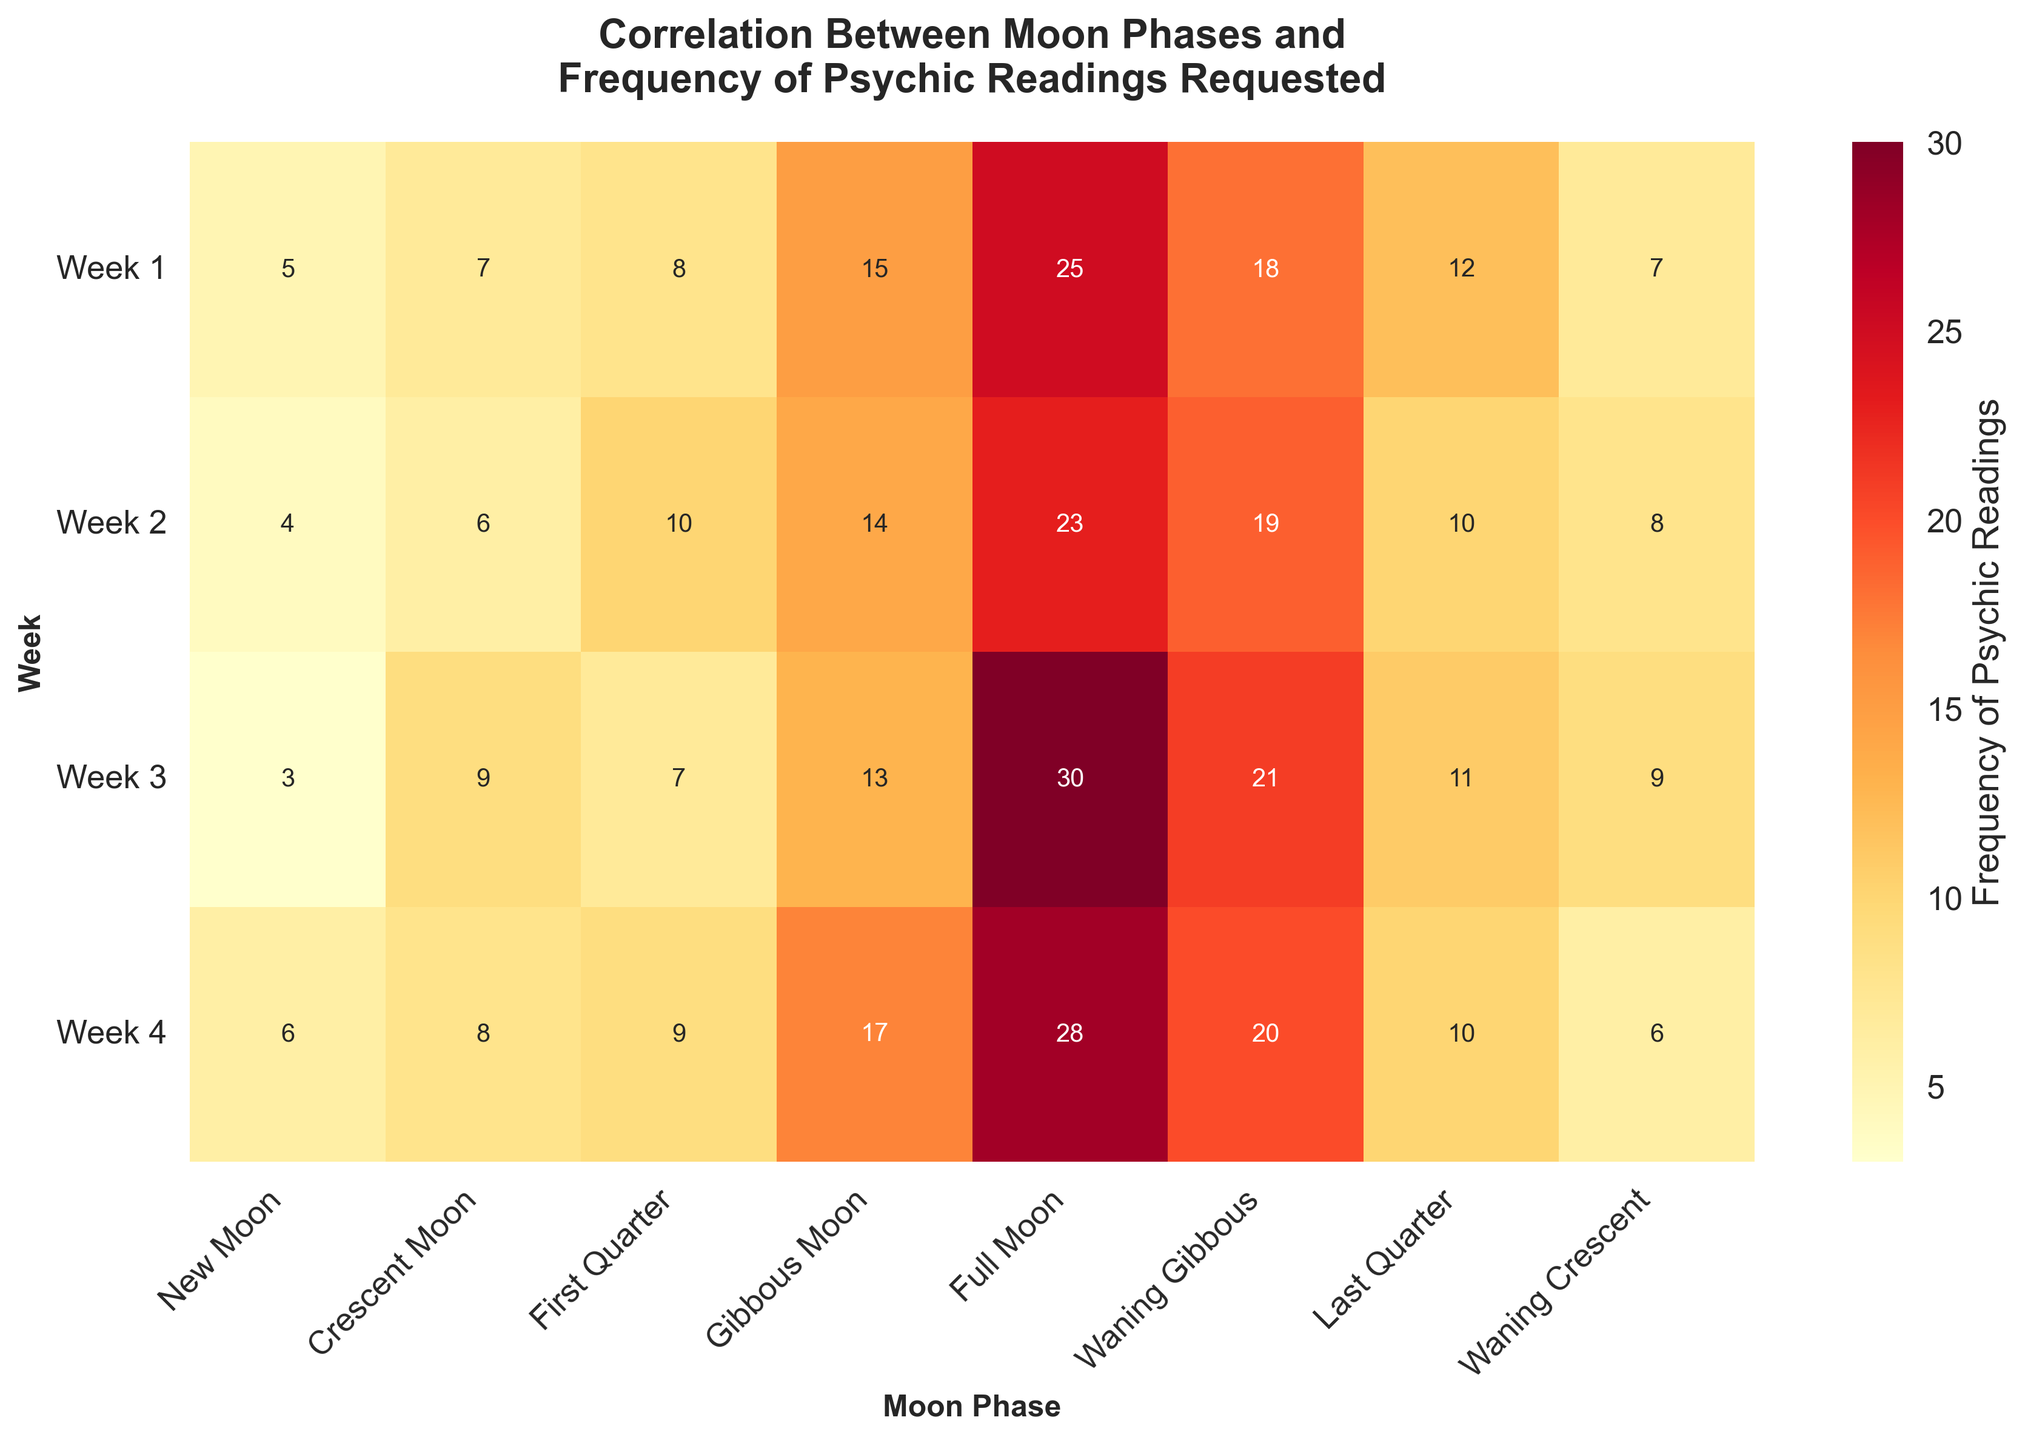What is the title of the figure? The title of the figure is generally displayed at the top. Here it says 'Correlation Between Moon Phases and Frequency of Psychic Readings Requested'.
Answer: Correlation Between Moon Phases and Frequency of Psychic Readings Requested Which Moon Phase has the highest frequency of psychic readings requested in Week 3? To determine this, look at the row labeled 'Week 3' and find the highest value. The highest value in this row is 30, which corresponds to the 'Full Moon'.
Answer: Full Moon What is the sum of psychic readings requested for the 'Waning Gibbous' phase across all weeks? Look at the 'Waning Gibbous' column and add the values: 18 + 19 + 21 + 20. The total is 78.
Answer: 78 Which Moon Phase has the lowest total frequency of psychic readings requested across all weeks? To find this, sum the frequency of psychic readings across all weeks for each Moon Phase and identify the lowest sum. The sums are calculated as follows: New Moon (5+4+3+6=18), Crescent Moon (7+6+9+8=30), etc. The 'New Moon' has the lowest total which is 18.
Answer: New Moon What is the average frequency of psychic readings requested during the 'Full Moon' phase? To calculate the average, sum the values in the 'Full Moon' column and divide by the number of weeks. The values are 25, 23, 30, and 28. Sum these to get 106, and divide by 4, which gives 26.5.
Answer: 26.5 Which week has the highest total frequency of psychic readings requested across all Moon Phases? Add the values for each Moon Phase within a week and compare the totals. For Week 1: 5+7+8+15+25+18+12+7=97, Week 2: 94, Week 3: 93, and Week 4: 104. Week 4 has the highest total which is 104.
Answer: Week 4 What is the difference in the frequency of psychic readings requested between the 'First Quarter' and 'Last Quarter' Moon Phases during Week 1? Look at the values in Week 1 for 'First Quarter' and 'Last Quarter'. They are 8 and 12. The difference is 12 - 8 = 4.
Answer: 4 How does the frequency of psychic readings requested change from the 'New Moon' to the 'Full Moon' during Week 2? Look at the values for Week 2 from 'New Moon' (4) to 'Full Moon' (14). The frequency increases by 10 readings (14 - 4 = 10).
Answer: Increases by 10 